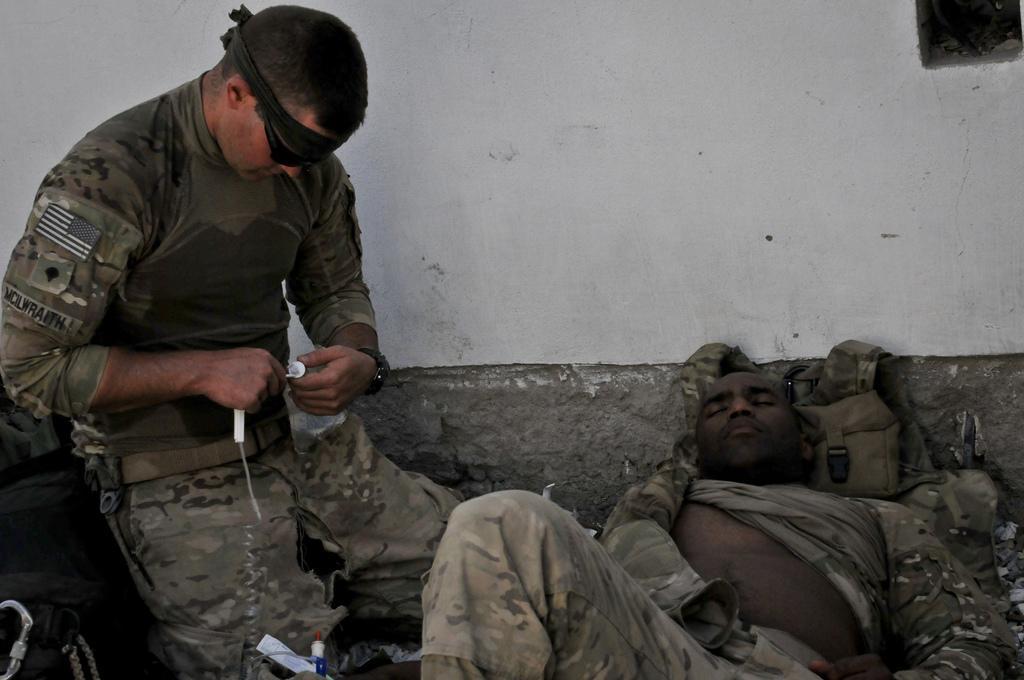Could you give a brief overview of what you see in this image? In this picture we can see a man is lying and behind the man, there is a bag and a wall. On the left side of the man, there is another man holding some objects. In the bottom left corner of the image, there is a black object. 